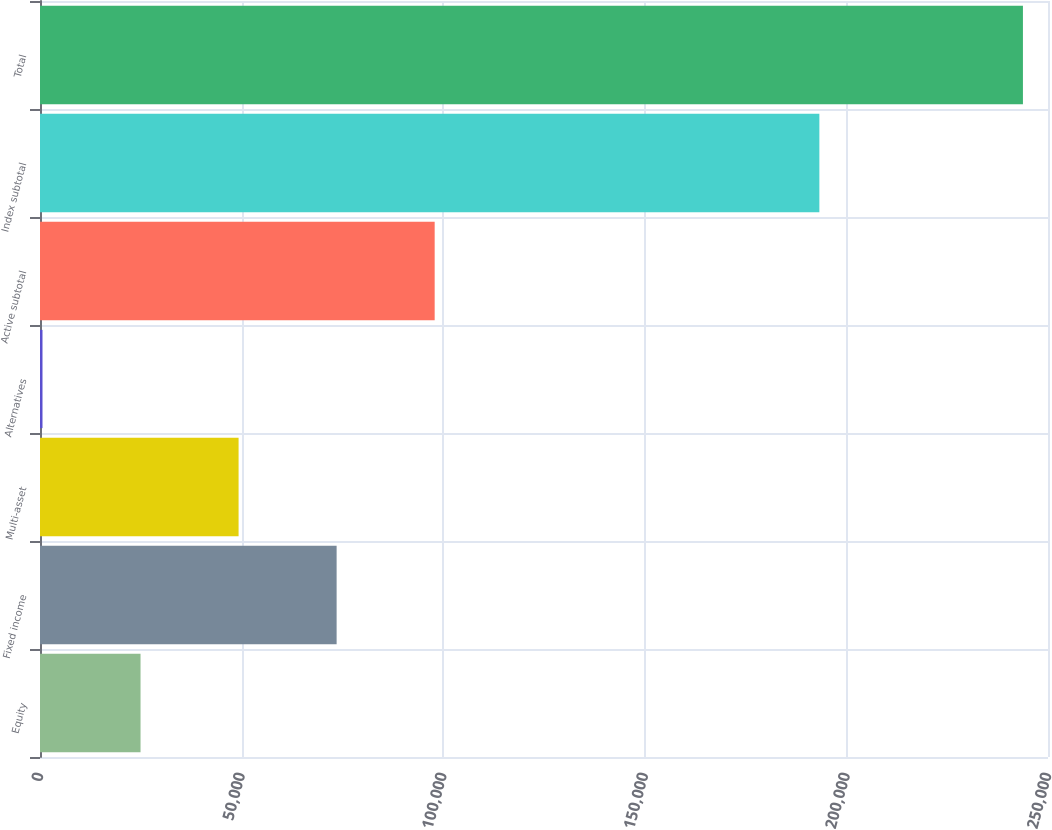Convert chart to OTSL. <chart><loc_0><loc_0><loc_500><loc_500><bar_chart><fcel>Equity<fcel>Fixed income<fcel>Multi-asset<fcel>Alternatives<fcel>Active subtotal<fcel>Index subtotal<fcel>Total<nl><fcel>24935.5<fcel>73568.5<fcel>49252<fcel>619<fcel>97885<fcel>193295<fcel>243784<nl></chart> 